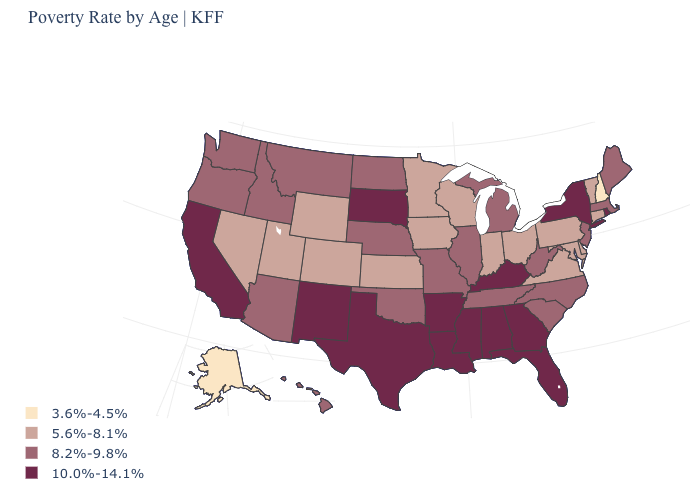How many symbols are there in the legend?
Quick response, please. 4. What is the value of Delaware?
Quick response, please. 5.6%-8.1%. How many symbols are there in the legend?
Quick response, please. 4. What is the lowest value in the USA?
Short answer required. 3.6%-4.5%. Which states have the highest value in the USA?
Short answer required. Alabama, Arkansas, California, Florida, Georgia, Kentucky, Louisiana, Mississippi, New Mexico, New York, Rhode Island, South Dakota, Texas. What is the value of North Dakota?
Short answer required. 8.2%-9.8%. What is the value of Texas?
Short answer required. 10.0%-14.1%. Name the states that have a value in the range 8.2%-9.8%?
Short answer required. Arizona, Hawaii, Idaho, Illinois, Maine, Massachusetts, Michigan, Missouri, Montana, Nebraska, New Jersey, North Carolina, North Dakota, Oklahoma, Oregon, South Carolina, Tennessee, Washington, West Virginia. Among the states that border South Dakota , does Nebraska have the highest value?
Write a very short answer. Yes. Name the states that have a value in the range 10.0%-14.1%?
Give a very brief answer. Alabama, Arkansas, California, Florida, Georgia, Kentucky, Louisiana, Mississippi, New Mexico, New York, Rhode Island, South Dakota, Texas. Name the states that have a value in the range 10.0%-14.1%?
Concise answer only. Alabama, Arkansas, California, Florida, Georgia, Kentucky, Louisiana, Mississippi, New Mexico, New York, Rhode Island, South Dakota, Texas. Among the states that border South Dakota , does Minnesota have the lowest value?
Answer briefly. Yes. Which states hav the highest value in the West?
Be succinct. California, New Mexico. Name the states that have a value in the range 5.6%-8.1%?
Give a very brief answer. Colorado, Connecticut, Delaware, Indiana, Iowa, Kansas, Maryland, Minnesota, Nevada, Ohio, Pennsylvania, Utah, Vermont, Virginia, Wisconsin, Wyoming. What is the lowest value in states that border Missouri?
Short answer required. 5.6%-8.1%. 